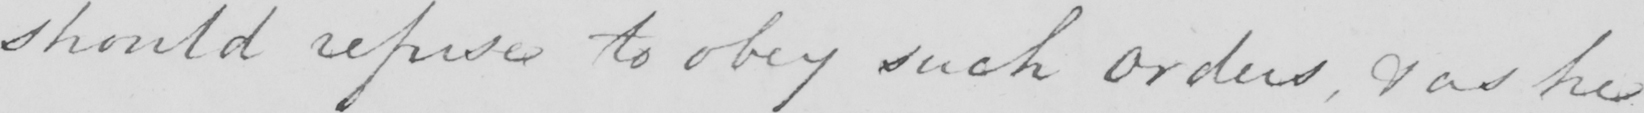What is written in this line of handwriting? should refuse to obey such Orders , & as he 